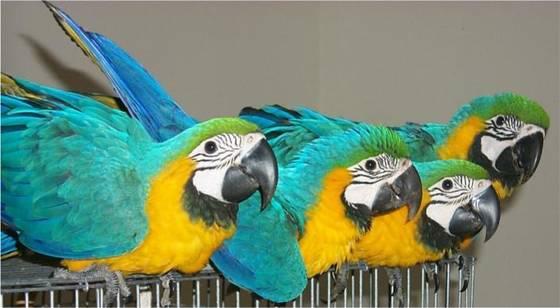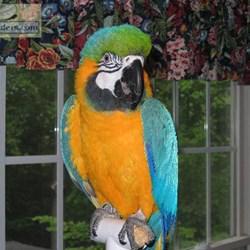The first image is the image on the left, the second image is the image on the right. Given the left and right images, does the statement "In one image there is a blue parrot sitting on a perch in the center of the image." hold true? Answer yes or no. Yes. The first image is the image on the left, the second image is the image on the right. Considering the images on both sides, is "there are 3 parrots in the image pair" valid? Answer yes or no. No. 